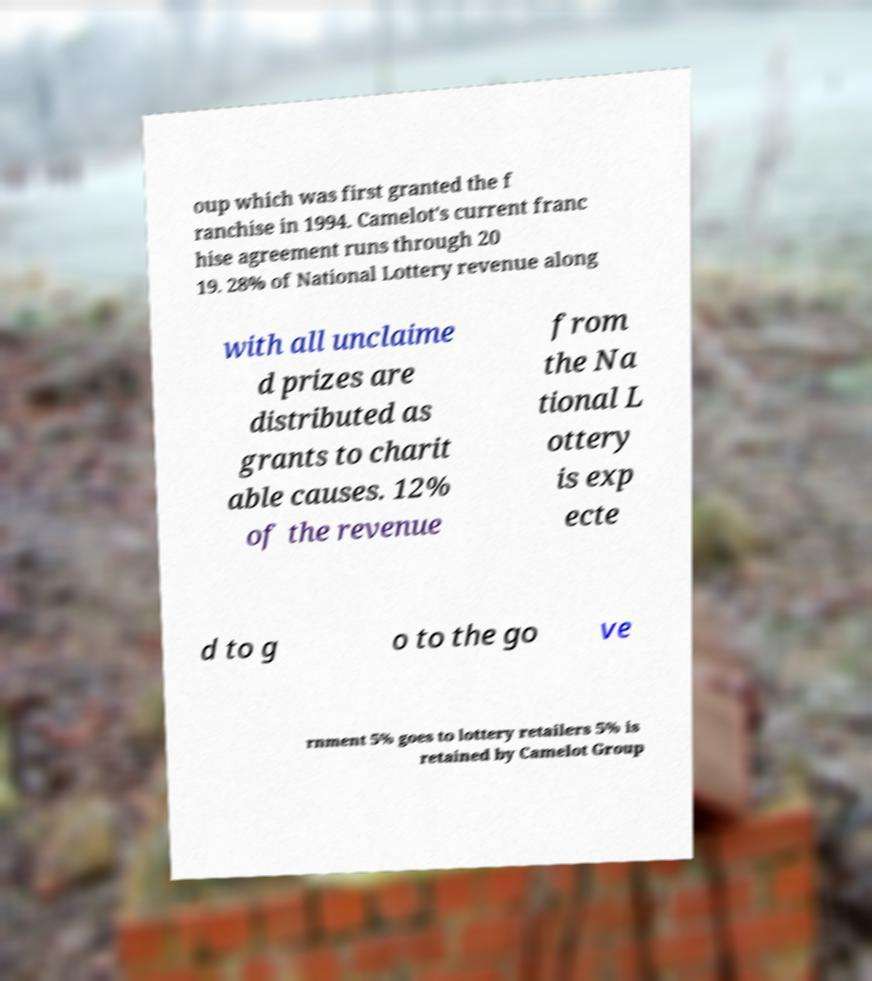Can you read and provide the text displayed in the image?This photo seems to have some interesting text. Can you extract and type it out for me? oup which was first granted the f ranchise in 1994. Camelot's current franc hise agreement runs through 20 19. 28% of National Lottery revenue along with all unclaime d prizes are distributed as grants to charit able causes. 12% of the revenue from the Na tional L ottery is exp ecte d to g o to the go ve rnment 5% goes to lottery retailers 5% is retained by Camelot Group 